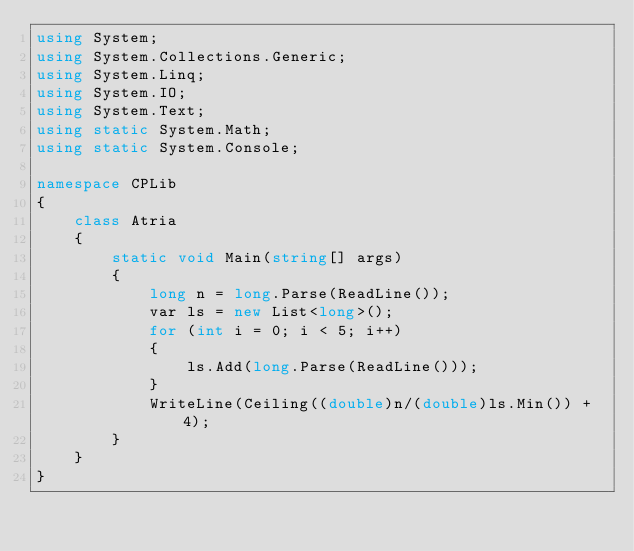Convert code to text. <code><loc_0><loc_0><loc_500><loc_500><_C#_>using System;
using System.Collections.Generic;
using System.Linq;
using System.IO;
using System.Text;
using static System.Math;
using static System.Console;

namespace CPLib
{
    class Atria
    {
        static void Main(string[] args)
        {
            long n = long.Parse(ReadLine());
            var ls = new List<long>();
            for (int i = 0; i < 5; i++)
            {
                ls.Add(long.Parse(ReadLine()));
            }
            WriteLine(Ceiling((double)n/(double)ls.Min()) + 4);
        }
    }
}
</code> 